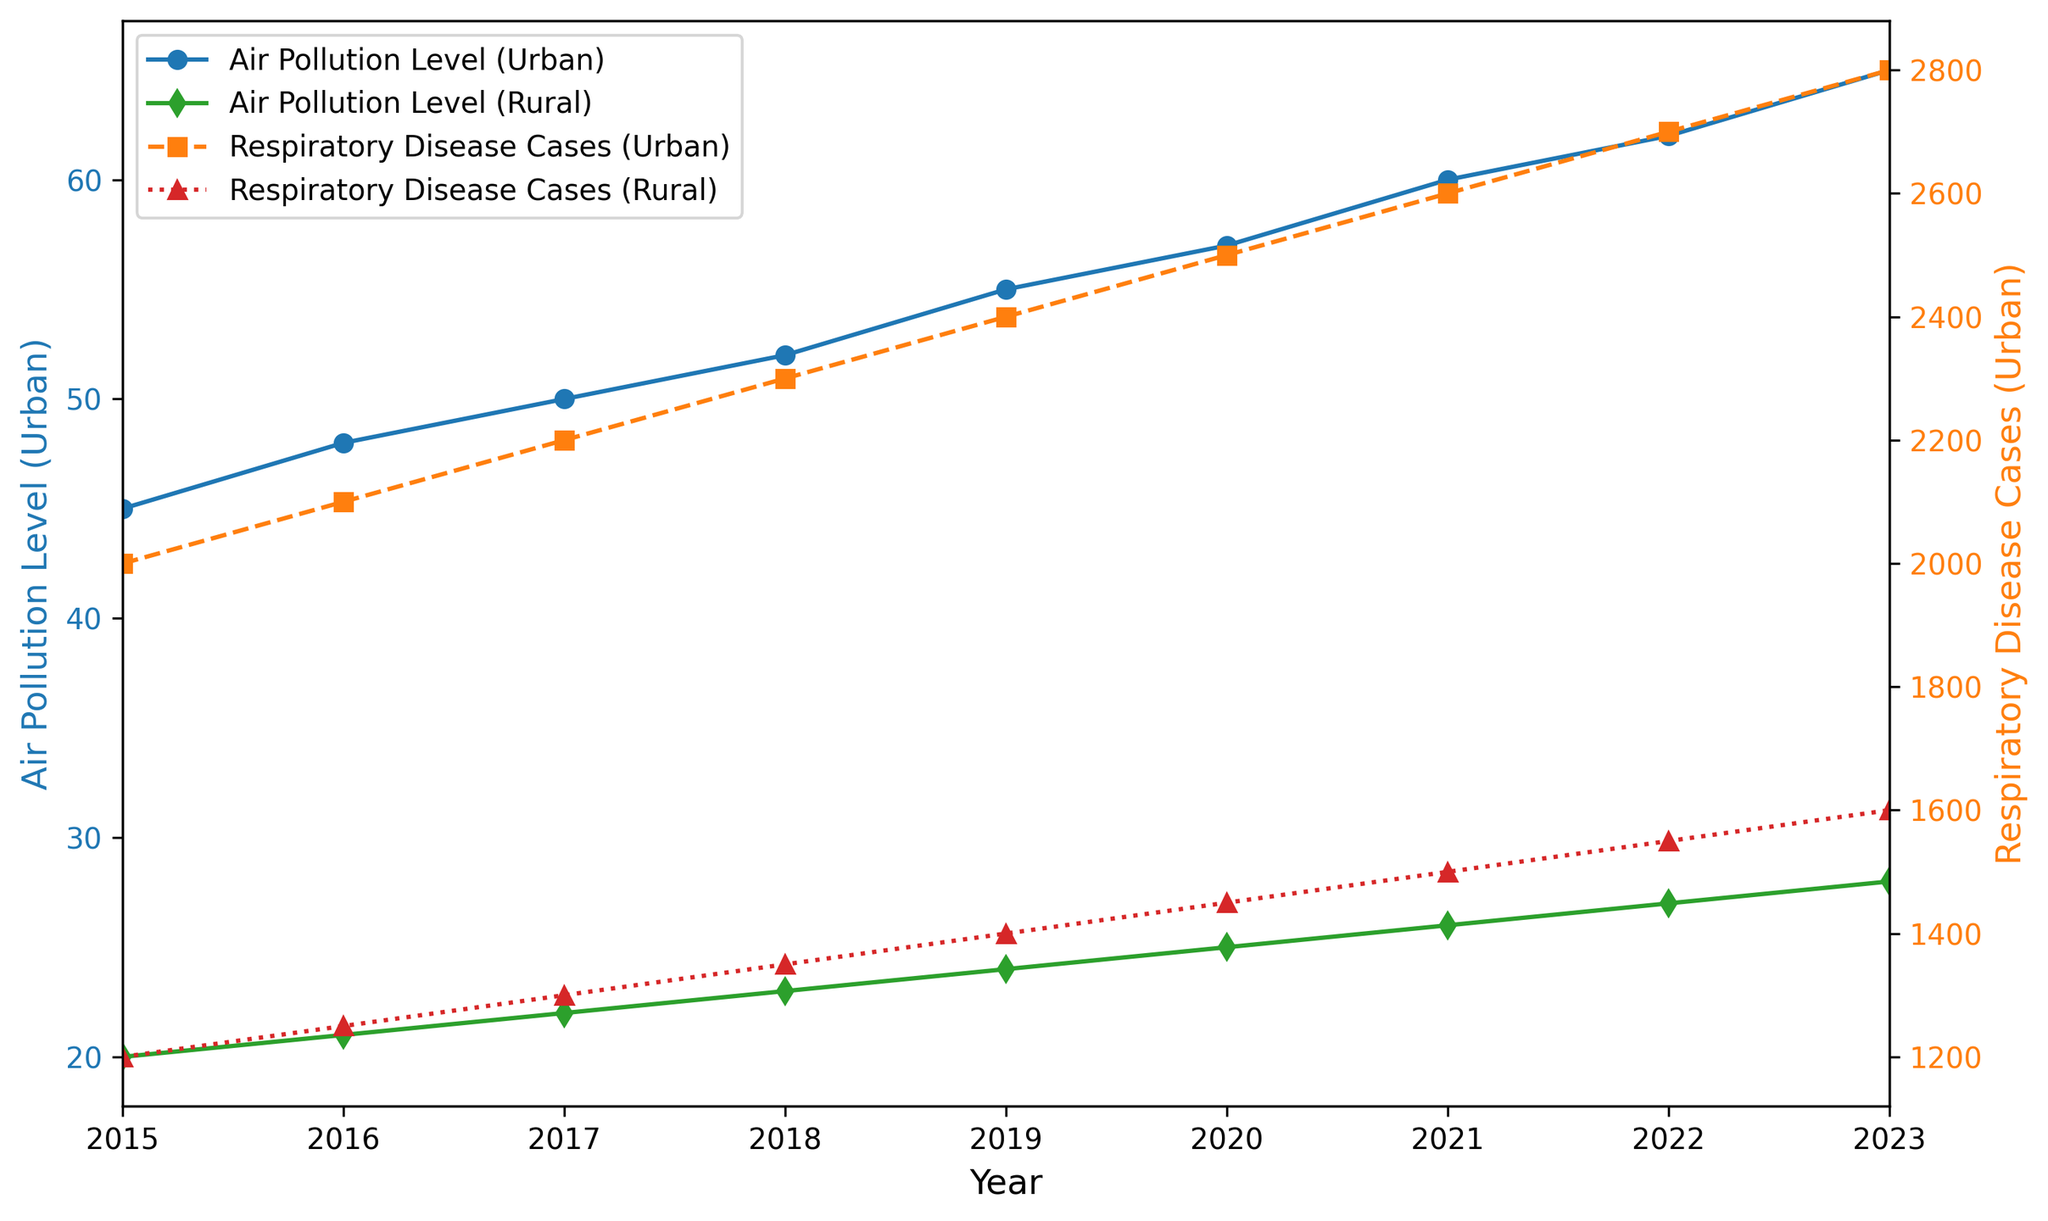What trend do you observe in air pollution levels in urban areas from 2015 to 2023? The air pollution levels in urban areas show a continuous upward trend from 45 in 2015 to 65 in 2023.
Answer: Continuous upward trend Which year has the highest number of respiratory disease cases in rural areas? By looking at the line for respiratory disease cases in rural areas, the highest value is observed in 2023 with 1600 cases.
Answer: 2023 Compare the air pollution levels between urban and rural areas in 2018. Which location has a higher level? In 2018, the air pollution level in the urban area is 52, while in the rural area it is 23. The urban area has a higher level of air pollution.
Answer: Urban area What's the difference in respiratory disease cases between urban and rural areas in 2023? In 2023, the urban area has 2800 respiratory disease cases, and the rural area has 1600 cases. The difference is 2800 - 1600 = 1200.
Answer: 1200 By how much did air pollution levels increase in rural areas from 2015 to 2023? The air pollution level in rural areas increased from 20 in 2015 to 28 in 2023. The increase is 28 - 20 = 8.
Answer: 8 Which location has a higher increase in respiratory disease cases from 2015 to 2023, urban or rural? In the urban area, the cases increased from 2000 in 2015 to 2800 in 2023, a difference of 800. In the rural area, the cases increased from 1200 to 1600, a difference of 400. The urban area has a higher increase.
Answer: Urban area Do the respiratory disease cases trend similarly to the air pollution levels in urban areas? Both respiratory disease cases and air pollution levels in urban areas show an increasing trend from 2015 to 2023.
Answer: Yes What is the visual difference between the markers used for air pollution levels in urban and rural areas? The markers for air pollution levels in urban areas are circles (o), while for rural areas they are diamonds (d).
Answer: Circles vs. Diamonds 